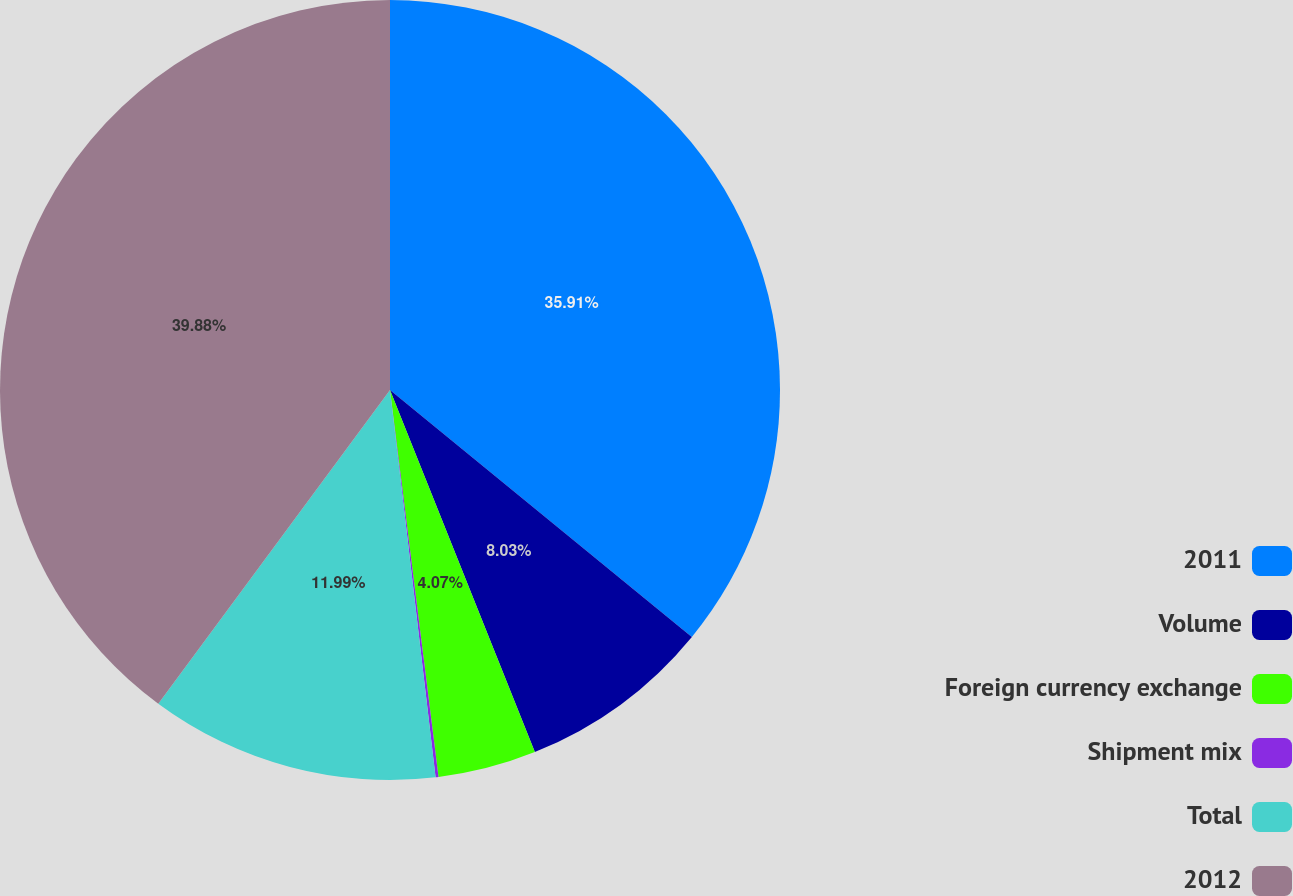<chart> <loc_0><loc_0><loc_500><loc_500><pie_chart><fcel>2011<fcel>Volume<fcel>Foreign currency exchange<fcel>Shipment mix<fcel>Total<fcel>2012<nl><fcel>35.91%<fcel>8.03%<fcel>4.07%<fcel>0.12%<fcel>11.99%<fcel>39.87%<nl></chart> 